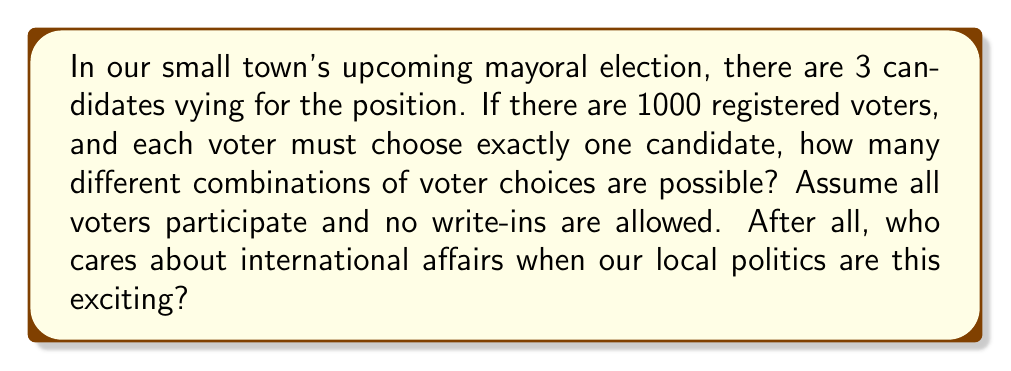Show me your answer to this math problem. Let's break this down step-by-step:

1) Each voter has 3 choices (the 3 candidates).

2) There are 1000 voters, and each voter's choice is independent of the others.

3) This scenario is a perfect example of the Multiplication Principle in combinatorics.

4) When we have $n$ independent events, and each event has $k$ possible outcomes, the total number of possible outcomes is $k^n$.

5) In this case:
   - $k = 3$ (number of candidates)
   - $n = 1000$ (number of voters)

6) Therefore, the total number of possible combinations is:

   $$3^{1000}$$

7) This is an extremely large number. To give you an idea of its magnitude:

   $$3^{1000} \approx 1.3 \times 10^{477}$$

8) This number is so large that it exceeds the estimated number of atoms in the observable universe!
Answer: $3^{1000}$ 